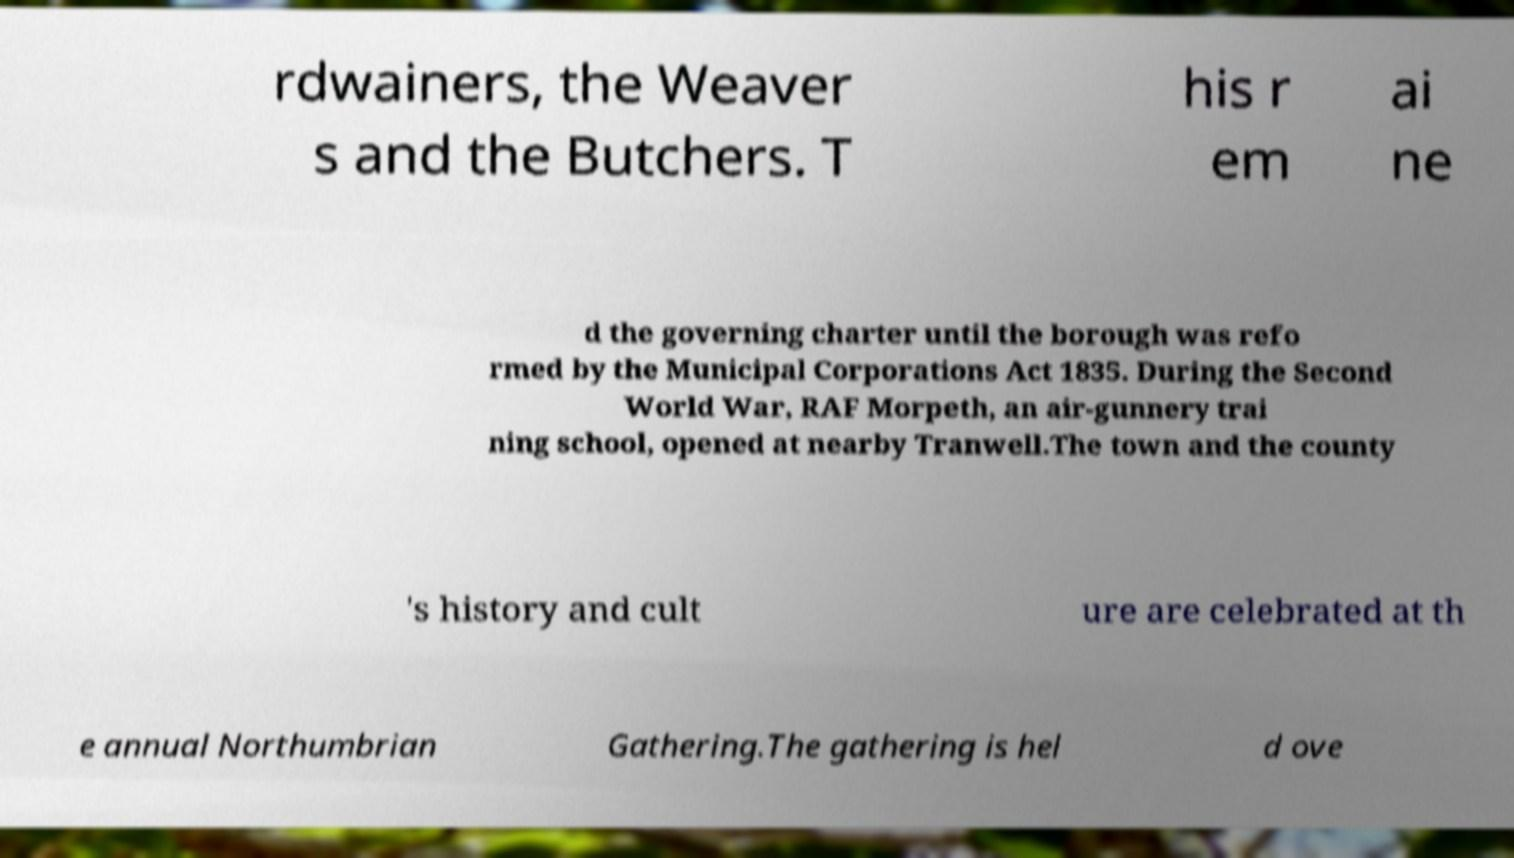Could you assist in decoding the text presented in this image and type it out clearly? rdwainers, the Weaver s and the Butchers. T his r em ai ne d the governing charter until the borough was refo rmed by the Municipal Corporations Act 1835. During the Second World War, RAF Morpeth, an air-gunnery trai ning school, opened at nearby Tranwell.The town and the county 's history and cult ure are celebrated at th e annual Northumbrian Gathering.The gathering is hel d ove 